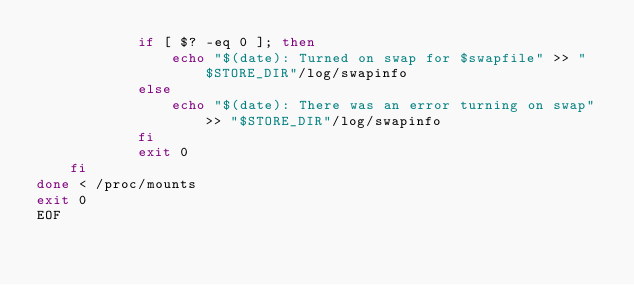Convert code to text. <code><loc_0><loc_0><loc_500><loc_500><_Bash_>            if [ $? -eq 0 ]; then
                echo "$(date): Turned on swap for $swapfile" >> "$STORE_DIR"/log/swapinfo
            else
                echo "$(date): There was an error turning on swap" >> "$STORE_DIR"/log/swapinfo
            fi
            exit 0
    fi
done < /proc/mounts
exit 0
EOF
</code> 